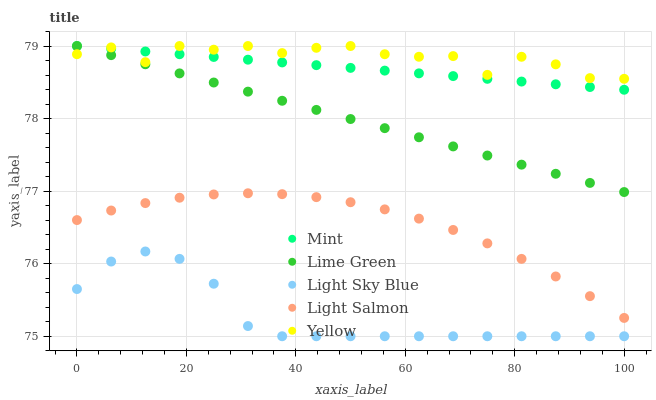Does Light Sky Blue have the minimum area under the curve?
Answer yes or no. Yes. Does Yellow have the maximum area under the curve?
Answer yes or no. Yes. Does Light Salmon have the minimum area under the curve?
Answer yes or no. No. Does Light Salmon have the maximum area under the curve?
Answer yes or no. No. Is Mint the smoothest?
Answer yes or no. Yes. Is Yellow the roughest?
Answer yes or no. Yes. Is Light Salmon the smoothest?
Answer yes or no. No. Is Light Salmon the roughest?
Answer yes or no. No. Does Light Sky Blue have the lowest value?
Answer yes or no. Yes. Does Light Salmon have the lowest value?
Answer yes or no. No. Does Yellow have the highest value?
Answer yes or no. Yes. Does Light Salmon have the highest value?
Answer yes or no. No. Is Light Sky Blue less than Lime Green?
Answer yes or no. Yes. Is Light Salmon greater than Light Sky Blue?
Answer yes or no. Yes. Does Yellow intersect Lime Green?
Answer yes or no. Yes. Is Yellow less than Lime Green?
Answer yes or no. No. Is Yellow greater than Lime Green?
Answer yes or no. No. Does Light Sky Blue intersect Lime Green?
Answer yes or no. No. 